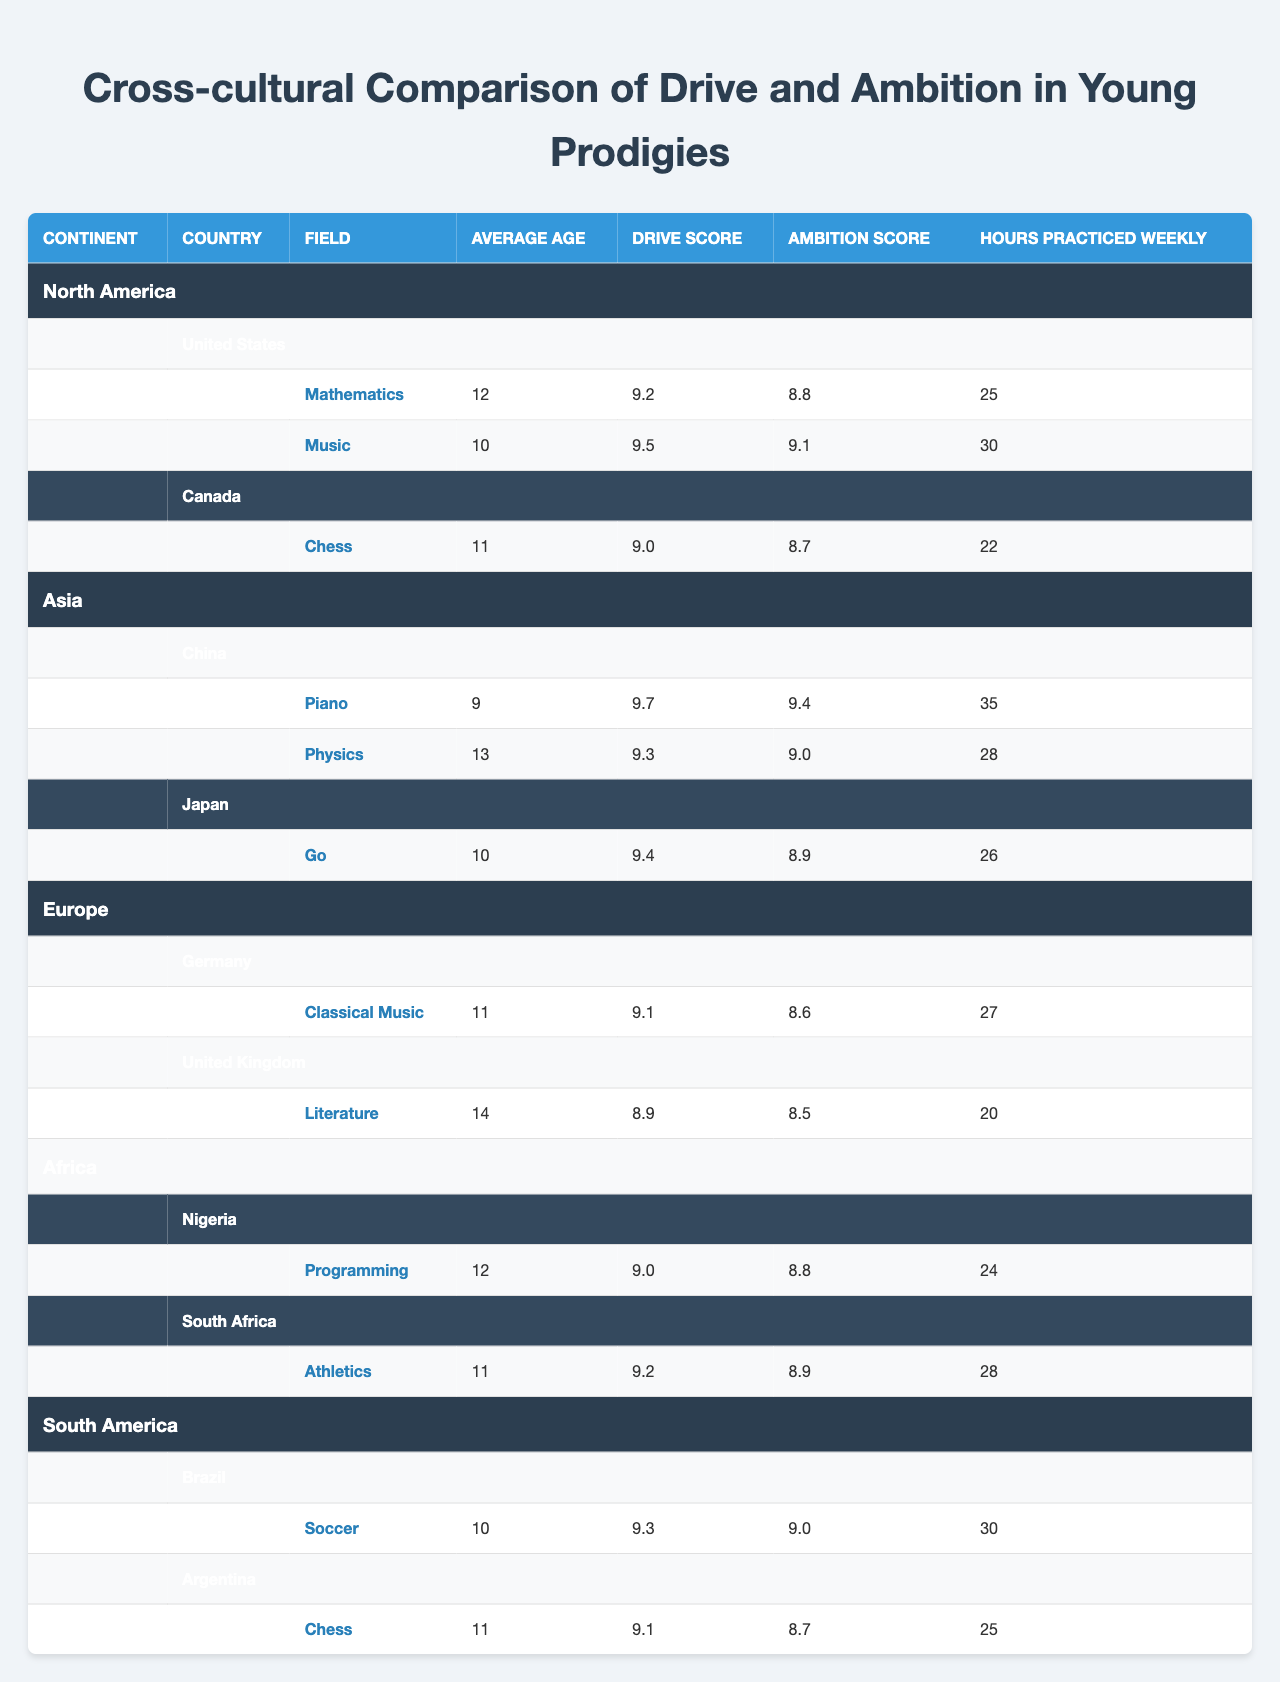What is the average drive score of prodigies from North America? The drive scores for prodigies in North America are 9.2, 9.5, and 9.0. To find the average, sum these values (9.2 + 9.5 + 9.0 = 27.7) and divide by the number of prodigies (3), which gives 27.7 / 3 = 9.23.
Answer: 9.23 Which prodigy has the highest ambition score in Asia? In Asia, the ambition scores are 9.4 for Piano, 9.0 for Physics, and 8.9 for Go. The highest score is 9.4 for the Piano prodigy in China.
Answer: 9.4 Is there a prodigy from Africa specializing in athletics? Yes, South Africa has a prodigy specializing in athletics as indicated in the table.
Answer: Yes What is the difference between the average practice hours of prodigies in South America and those in Europe? The average practice hours for South America (30 from Brazil, 25 from Argentina) is (30 + 25) / 2 = 27.5. In Europe (27 from Germany, 20 from the UK), it is (27 + 20) / 2 = 23.5. The difference is 27.5 - 23.5 = 4 hours.
Answer: 4 What is the most common field of expertise among prodigies in North America? North American prodigies are involved in Mathematics (2 prodigies) and Music (1 prodigy); thus, Mathematics is the most common field.
Answer: Mathematics What continent has prodigies practicing the most hours weekly? From the data, China's Piano prodigy practices 35 hours weekly, the highest among all continents.
Answer: Asia What is the average ambition score of prodigies in Europe? The ambition scores for Europe are 8.6 for Classical Music and 8.5 for Literature. The average is (8.6 + 8.5) / 2 = 8.55.
Answer: 8.55 Are there more prodigies in Asia or South America? Asia has 3 prodigies (2 from China, 1 from Japan), while South America has 2 prodigies (1 from Brazil, 1 from Argentina). Therefore, there are more prodigies in Asia.
Answer: Asia What field does the youngest prodigy in the table specialize in, and what is their average age? The youngest prodigy is from China, specializing in Piano with an average age of 9.
Answer: Piano, 9 How does the drive score of prodigies in Africa compare to those in Canada? The drive scores in Africa are 9.0 and 9.2 (for Nigeria and South Africa), averaging (9.0 + 9.2) / 2 = 9.1. In Canada, the drive score is 9.0. Therefore, the average score in Africa (9.1) is higher than in Canada (9.0).
Answer: Higher 